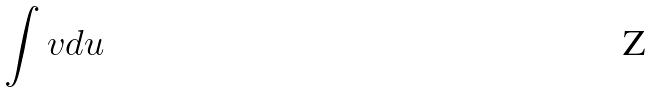Convert formula to latex. <formula><loc_0><loc_0><loc_500><loc_500>\int v d u</formula> 